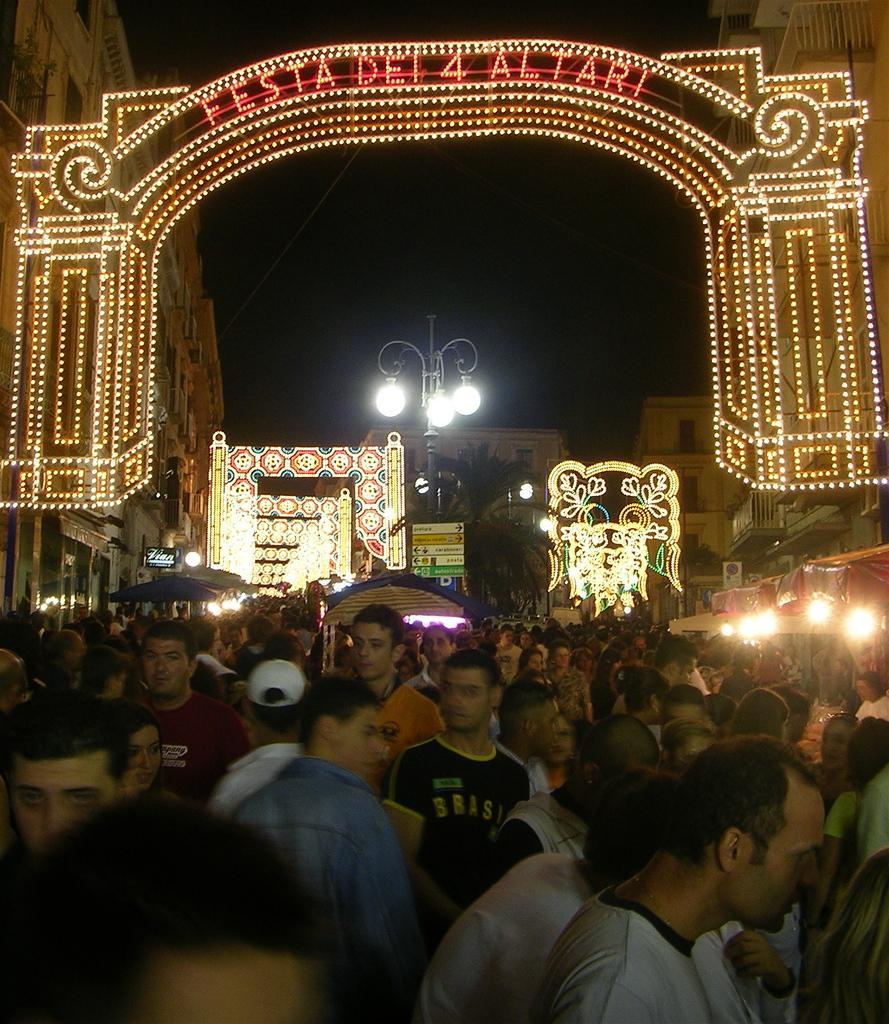Can you describe this image briefly? This picture shows few people standing and we see buildings and lights to the pole and we see lighting and a man wore cap on his head. 